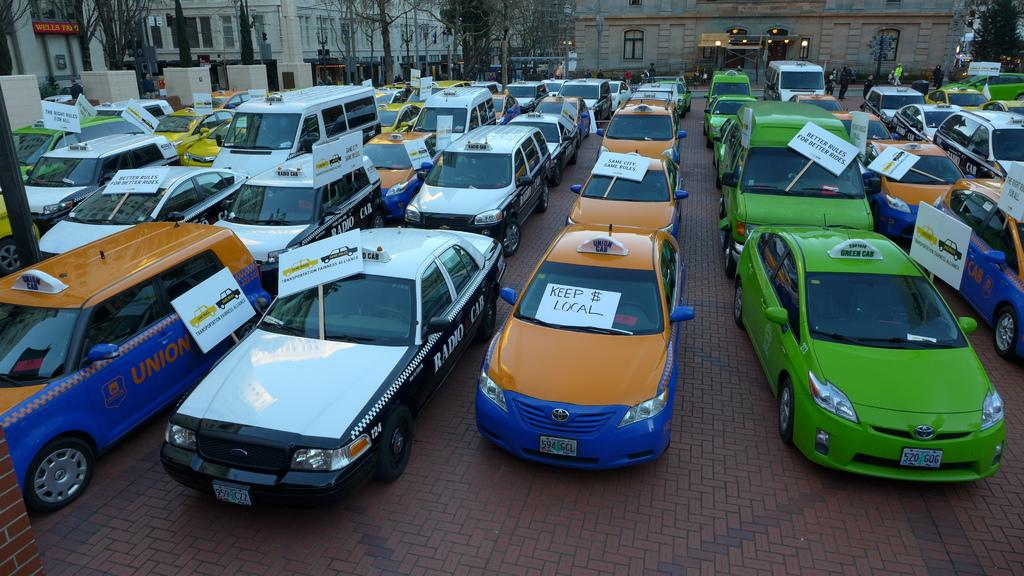<image>
Relay a brief, clear account of the picture shown. Union cabs, Radio cabs and Green cabs all in traffic together. 